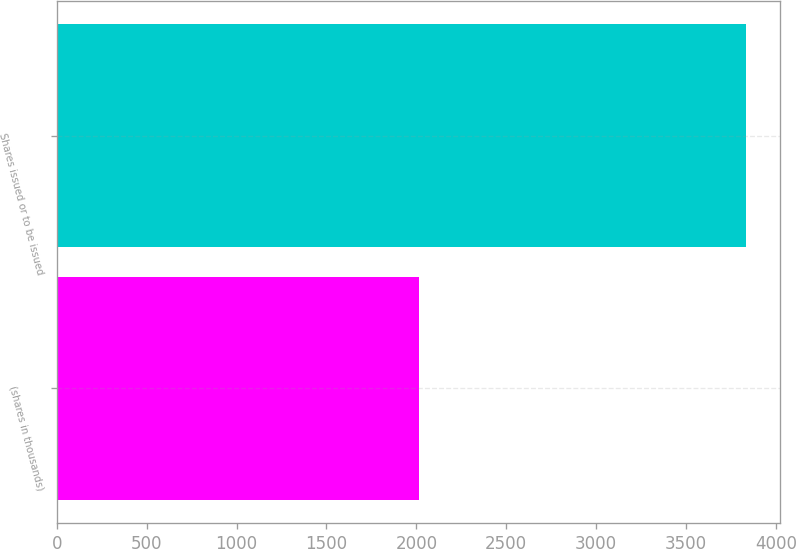Convert chart. <chart><loc_0><loc_0><loc_500><loc_500><bar_chart><fcel>(shares in thousands)<fcel>Shares issued or to be issued<nl><fcel>2013<fcel>3833<nl></chart> 